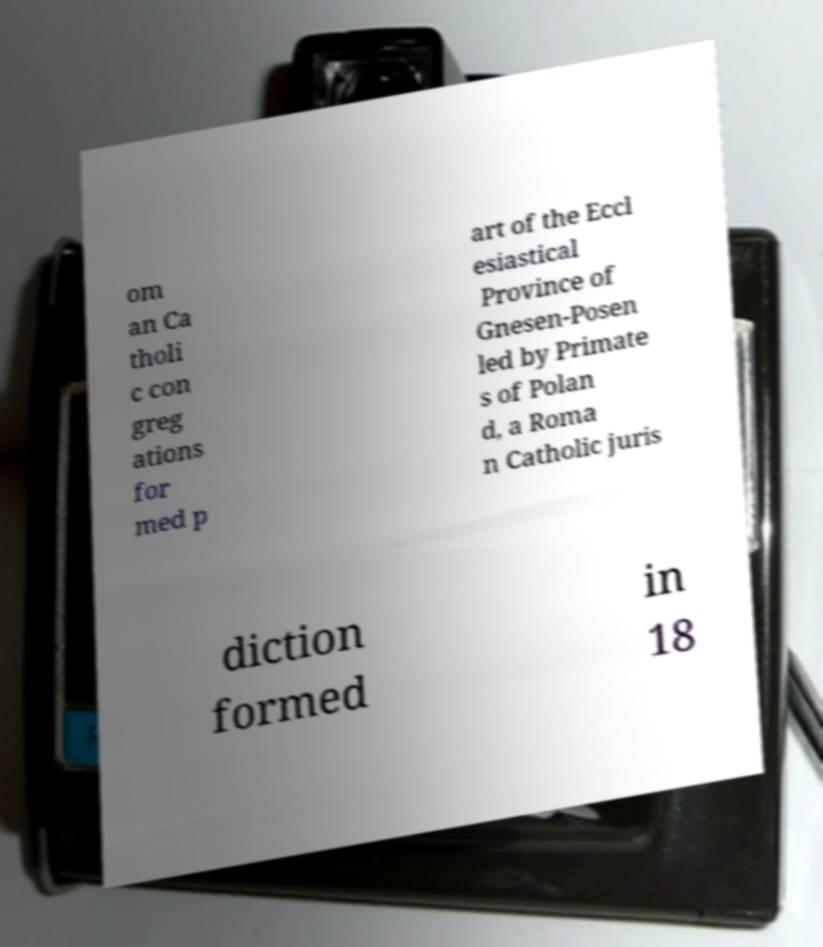Please identify and transcribe the text found in this image. om an Ca tholi c con greg ations for med p art of the Eccl esiastical Province of Gnesen-Posen led by Primate s of Polan d, a Roma n Catholic juris diction formed in 18 